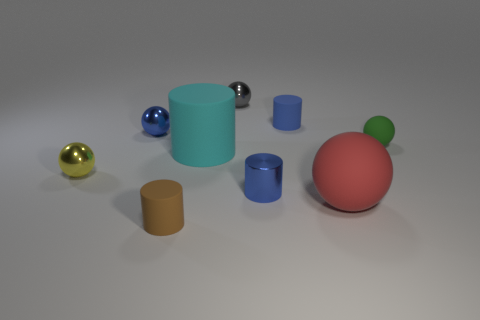Subtract all blue metallic spheres. How many spheres are left? 4 Add 1 green balls. How many objects exist? 10 Subtract all red cubes. How many blue cylinders are left? 2 Subtract 2 cylinders. How many cylinders are left? 2 Subtract all blue cylinders. How many cylinders are left? 2 Subtract all spheres. How many objects are left? 4 Subtract all blue rubber things. Subtract all gray things. How many objects are left? 7 Add 5 gray balls. How many gray balls are left? 6 Add 7 gray things. How many gray things exist? 8 Subtract 0 brown blocks. How many objects are left? 9 